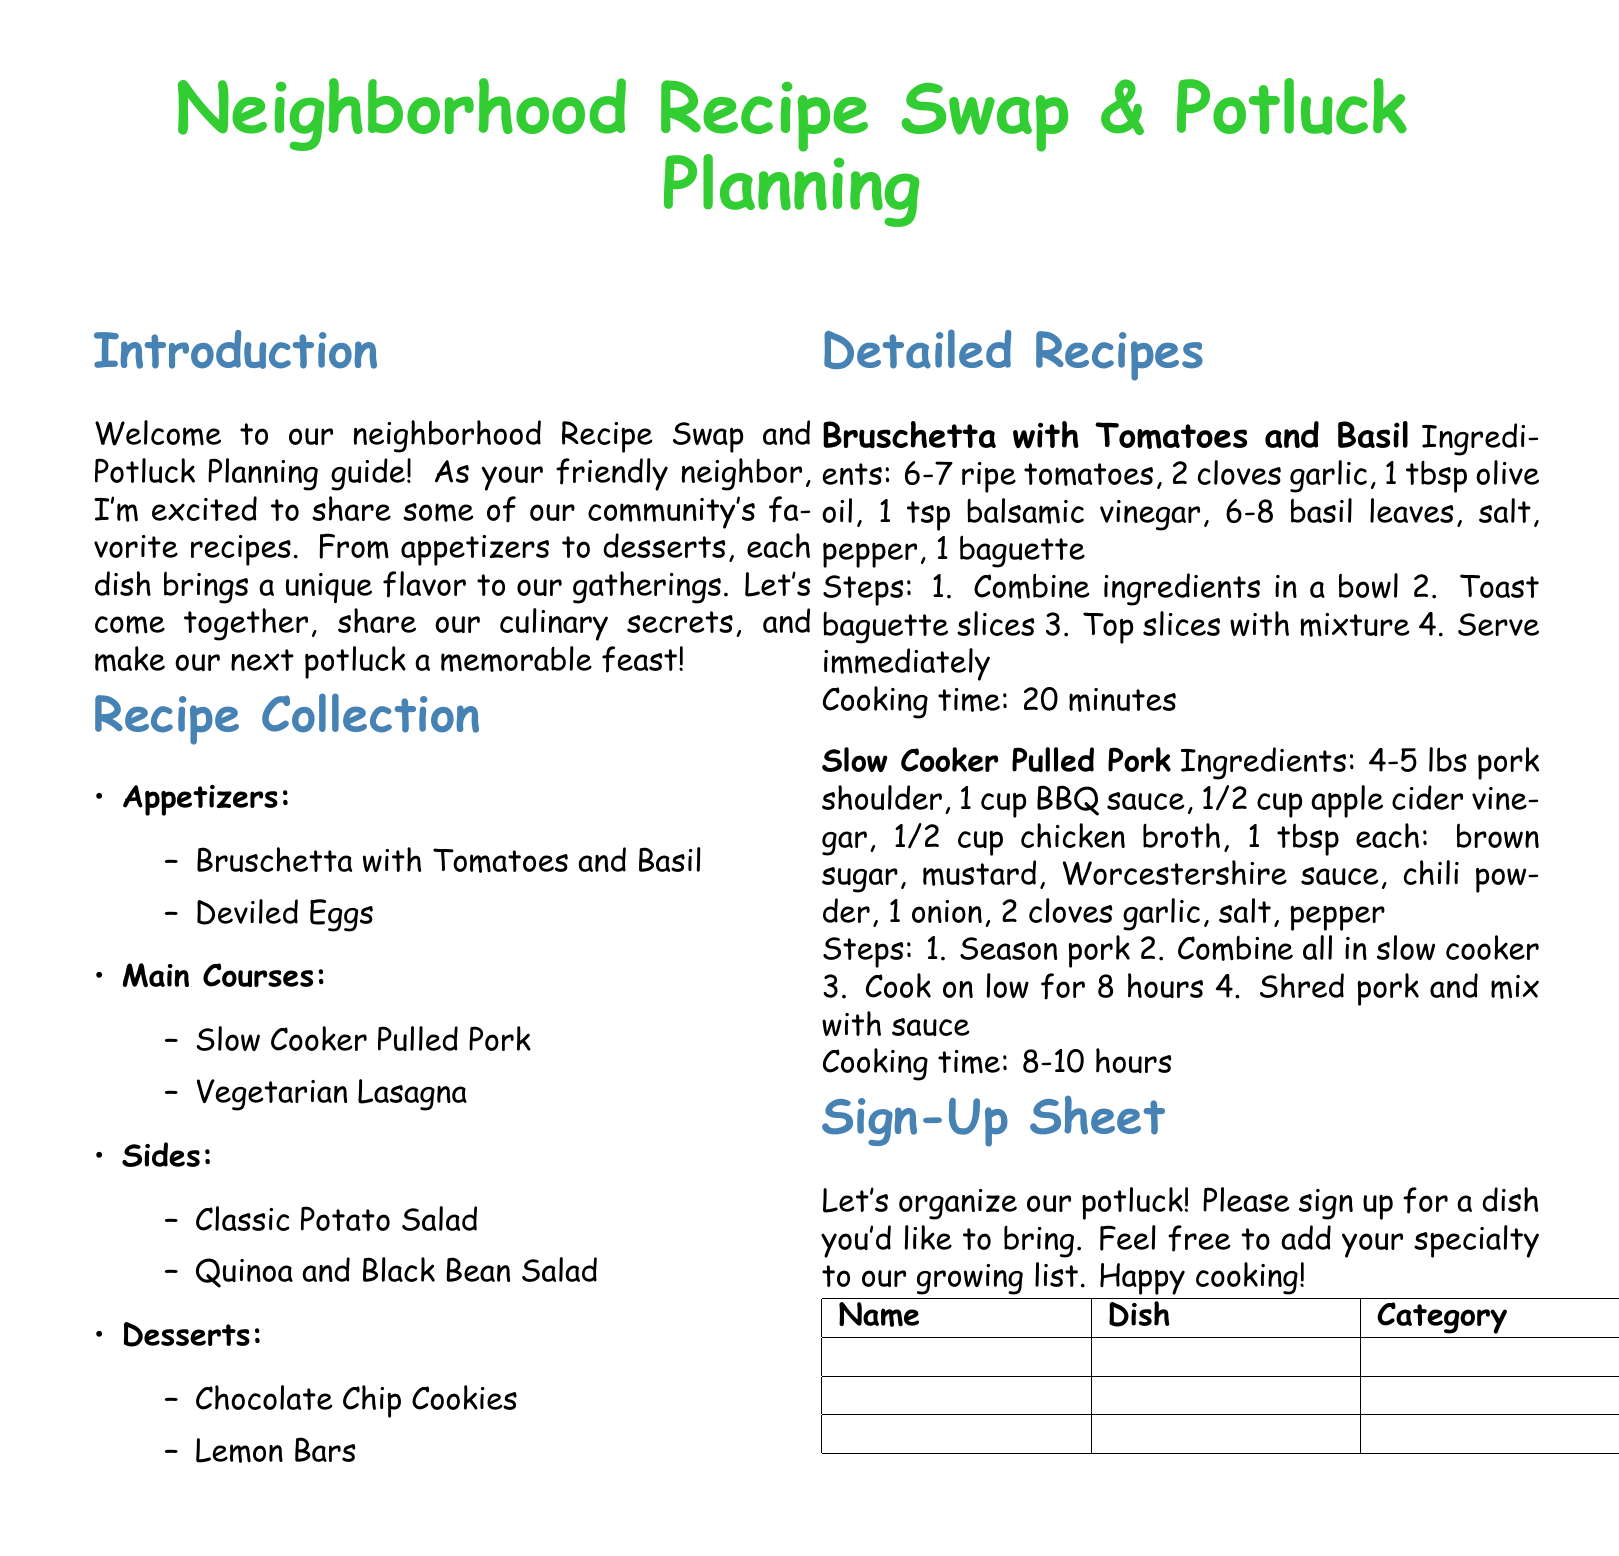What is the title of the document? The title is prominently displayed at the beginning of the document, introducing the topic.
Answer: Neighborhood Recipe Swap & Potluck Planning How many main course recipes are listed? By counting the recipes in the "Main Courses" section, we determine the total.
Answer: 2 What is the cooking time for Bruschetta with Tomatoes and Basil? The cooking time is specifically stated in the recipe section for this dish.
Answer: 20 minutes Which dish takes the longest cooking time? By comparing the cooking times noted for each recipe, we identify the one with the maximum duration.
Answer: Slow Cooker Pulled Pork What type of dish is Lemon Bars? The category for Lemon Bars is indicated in the recipe collection section.
Answer: Dessert How many ingredients are needed for Slow Cooker Pulled Pork? The number of unique ingredients is counted from the detailed recipe provided.
Answer: 10 